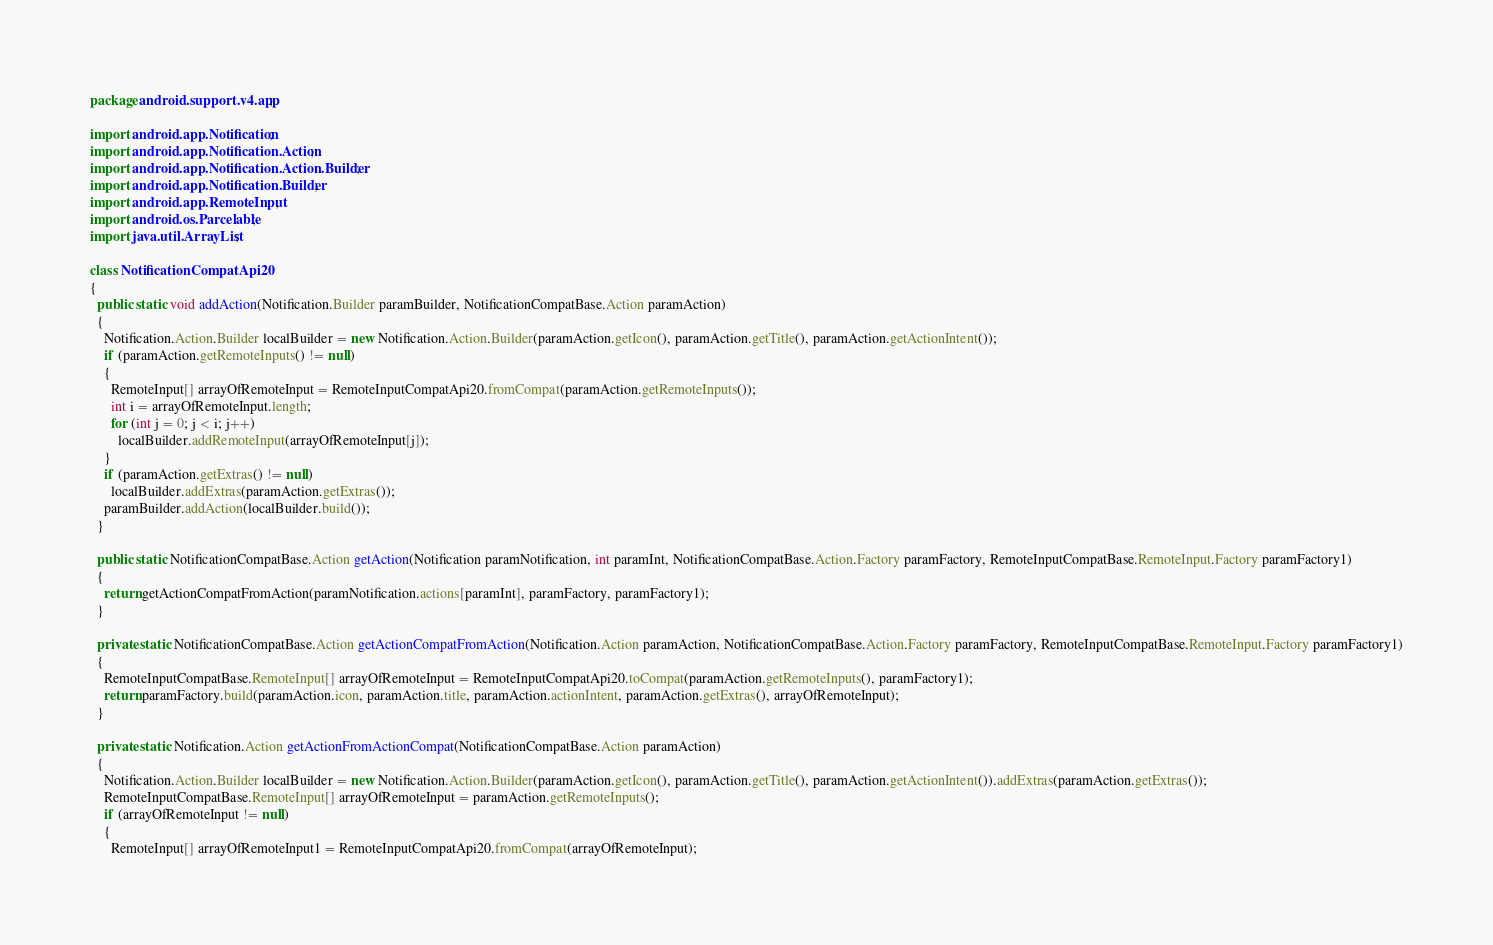Convert code to text. <code><loc_0><loc_0><loc_500><loc_500><_Java_>package android.support.v4.app;

import android.app.Notification;
import android.app.Notification.Action;
import android.app.Notification.Action.Builder;
import android.app.Notification.Builder;
import android.app.RemoteInput;
import android.os.Parcelable;
import java.util.ArrayList;

class NotificationCompatApi20
{
  public static void addAction(Notification.Builder paramBuilder, NotificationCompatBase.Action paramAction)
  {
    Notification.Action.Builder localBuilder = new Notification.Action.Builder(paramAction.getIcon(), paramAction.getTitle(), paramAction.getActionIntent());
    if (paramAction.getRemoteInputs() != null)
    {
      RemoteInput[] arrayOfRemoteInput = RemoteInputCompatApi20.fromCompat(paramAction.getRemoteInputs());
      int i = arrayOfRemoteInput.length;
      for (int j = 0; j < i; j++)
        localBuilder.addRemoteInput(arrayOfRemoteInput[j]);
    }
    if (paramAction.getExtras() != null)
      localBuilder.addExtras(paramAction.getExtras());
    paramBuilder.addAction(localBuilder.build());
  }

  public static NotificationCompatBase.Action getAction(Notification paramNotification, int paramInt, NotificationCompatBase.Action.Factory paramFactory, RemoteInputCompatBase.RemoteInput.Factory paramFactory1)
  {
    return getActionCompatFromAction(paramNotification.actions[paramInt], paramFactory, paramFactory1);
  }

  private static NotificationCompatBase.Action getActionCompatFromAction(Notification.Action paramAction, NotificationCompatBase.Action.Factory paramFactory, RemoteInputCompatBase.RemoteInput.Factory paramFactory1)
  {
    RemoteInputCompatBase.RemoteInput[] arrayOfRemoteInput = RemoteInputCompatApi20.toCompat(paramAction.getRemoteInputs(), paramFactory1);
    return paramFactory.build(paramAction.icon, paramAction.title, paramAction.actionIntent, paramAction.getExtras(), arrayOfRemoteInput);
  }

  private static Notification.Action getActionFromActionCompat(NotificationCompatBase.Action paramAction)
  {
    Notification.Action.Builder localBuilder = new Notification.Action.Builder(paramAction.getIcon(), paramAction.getTitle(), paramAction.getActionIntent()).addExtras(paramAction.getExtras());
    RemoteInputCompatBase.RemoteInput[] arrayOfRemoteInput = paramAction.getRemoteInputs();
    if (arrayOfRemoteInput != null)
    {
      RemoteInput[] arrayOfRemoteInput1 = RemoteInputCompatApi20.fromCompat(arrayOfRemoteInput);</code> 